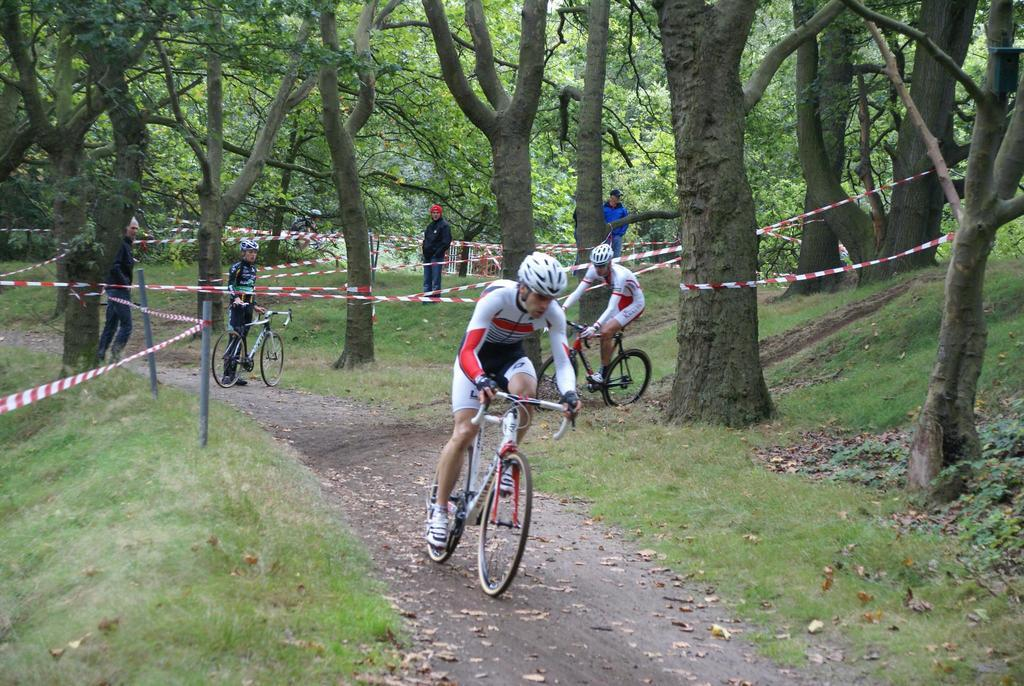How many people are in the image? There are many people in the image. What are the people doing in the image? The people are riding bicycles. What colors are the costumes of the people in the image? The people are wearing white, black, and black-and-white costumes. What can be seen in the background of the image? There is a path with trees on either side, and the path is on a grassland. What type of produce can be seen hanging from the trees on either side of the path? There is no produce visible in the image; only trees are present on either side of the path. 